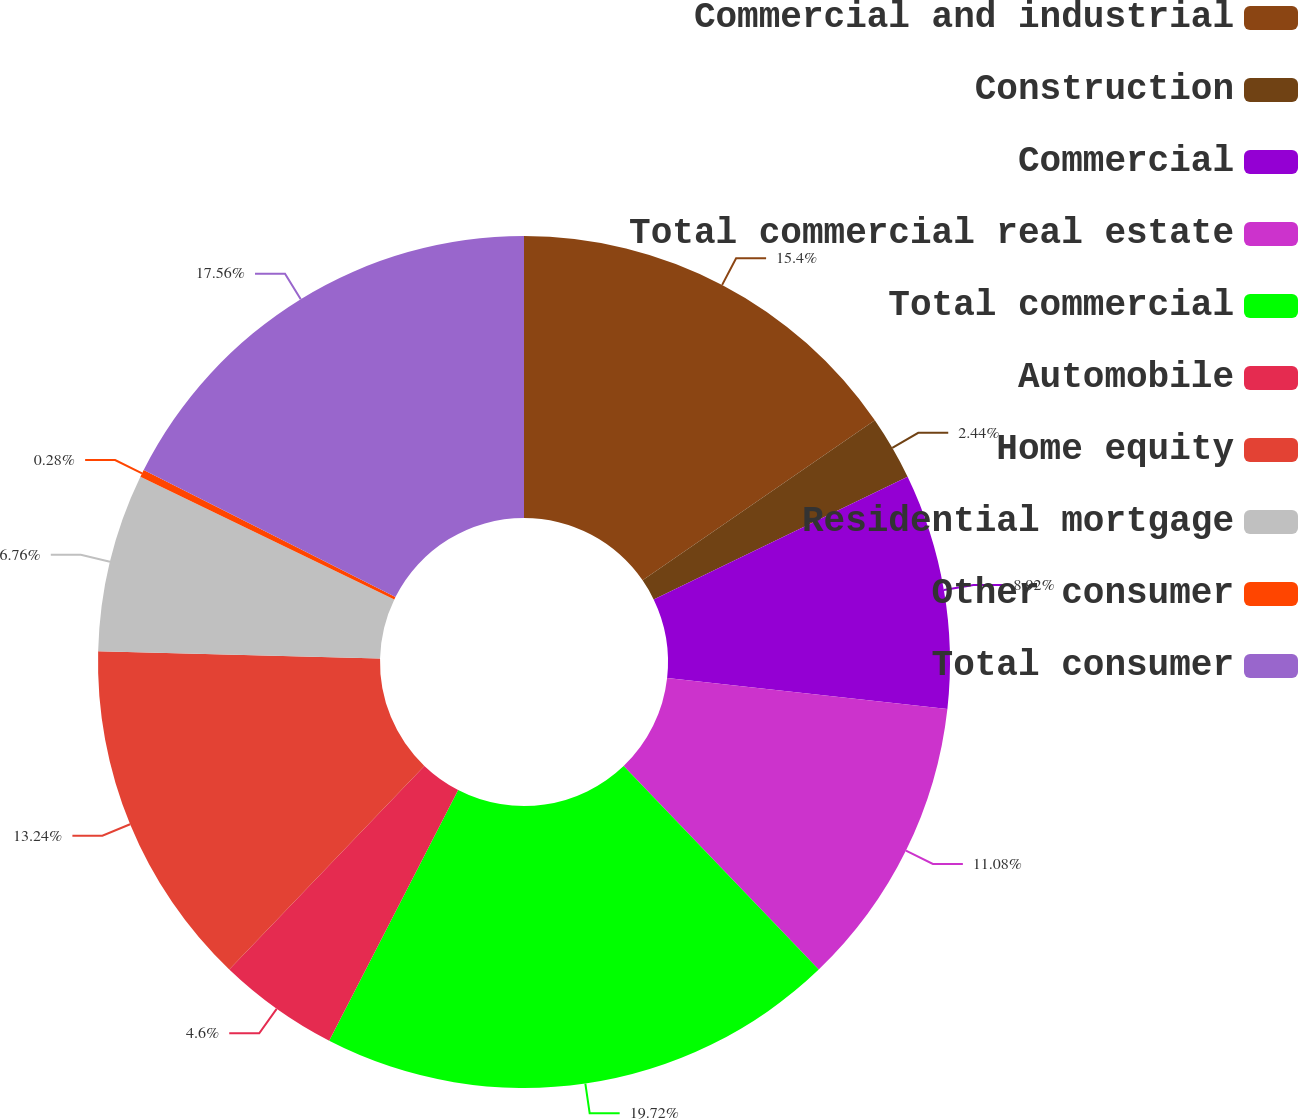Convert chart to OTSL. <chart><loc_0><loc_0><loc_500><loc_500><pie_chart><fcel>Commercial and industrial<fcel>Construction<fcel>Commercial<fcel>Total commercial real estate<fcel>Total commercial<fcel>Automobile<fcel>Home equity<fcel>Residential mortgage<fcel>Other consumer<fcel>Total consumer<nl><fcel>15.4%<fcel>2.44%<fcel>8.92%<fcel>11.08%<fcel>19.72%<fcel>4.6%<fcel>13.24%<fcel>6.76%<fcel>0.28%<fcel>17.56%<nl></chart> 